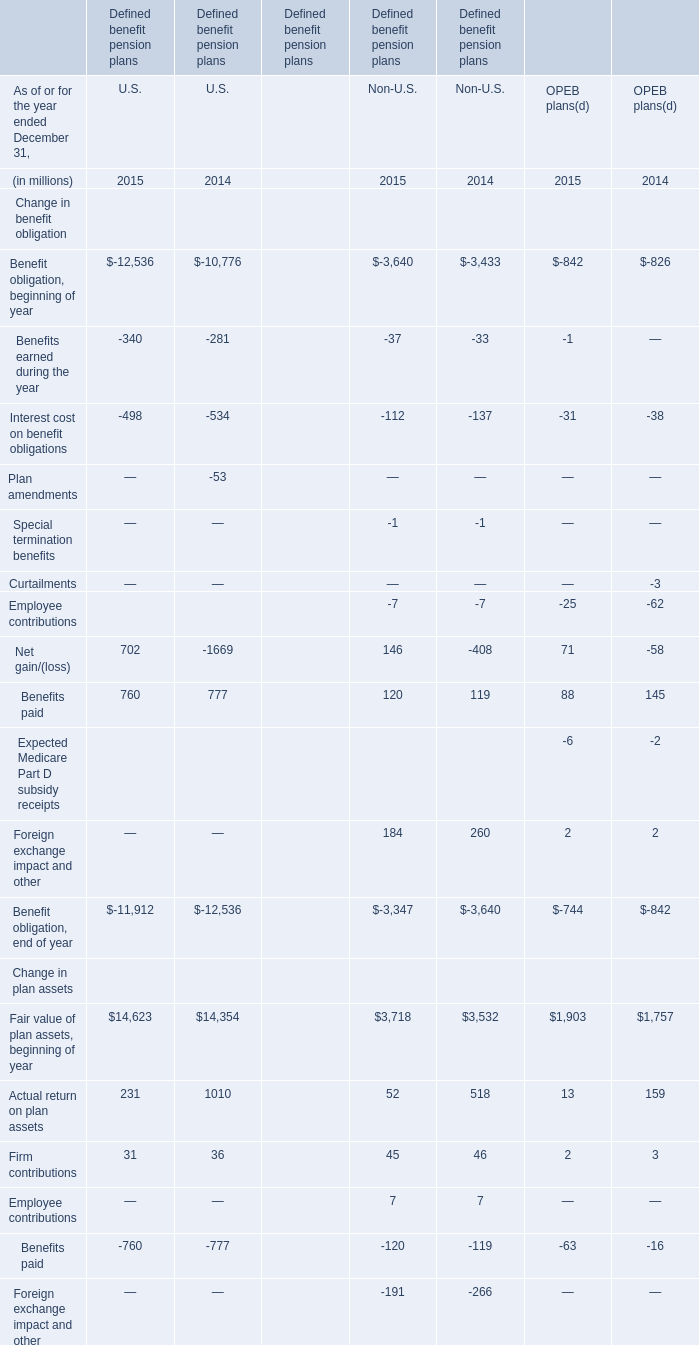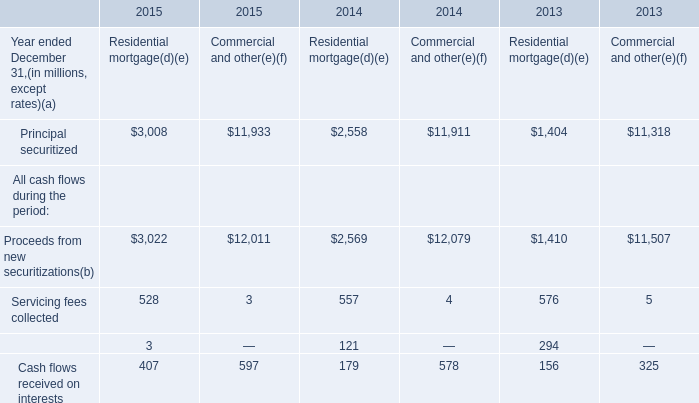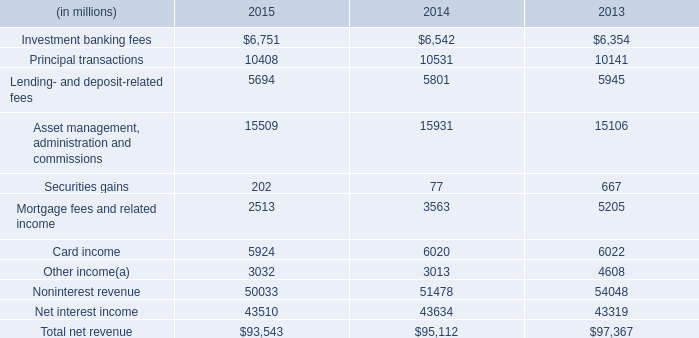What is the average amount of Principal securitized of 2014 Commercial and other, and Investment banking fees of 2014 ? 
Computations: ((11911.0 + 6542.0) / 2)
Answer: 9226.5. 